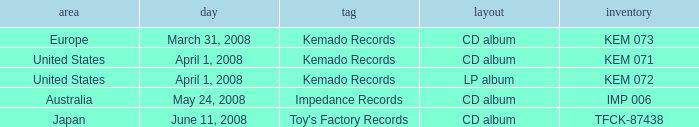Which Format has a Region of united states, and a Catalog of kem 072? LP album. 